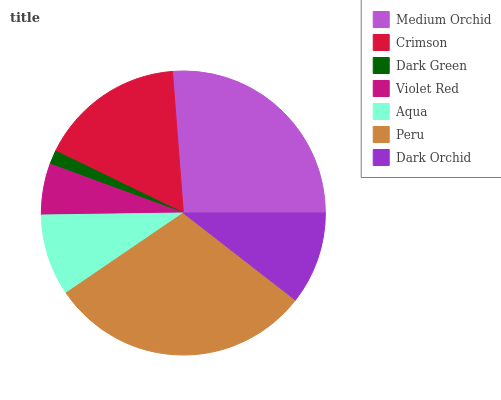Is Dark Green the minimum?
Answer yes or no. Yes. Is Peru the maximum?
Answer yes or no. Yes. Is Crimson the minimum?
Answer yes or no. No. Is Crimson the maximum?
Answer yes or no. No. Is Medium Orchid greater than Crimson?
Answer yes or no. Yes. Is Crimson less than Medium Orchid?
Answer yes or no. Yes. Is Crimson greater than Medium Orchid?
Answer yes or no. No. Is Medium Orchid less than Crimson?
Answer yes or no. No. Is Dark Orchid the high median?
Answer yes or no. Yes. Is Dark Orchid the low median?
Answer yes or no. Yes. Is Crimson the high median?
Answer yes or no. No. Is Dark Green the low median?
Answer yes or no. No. 